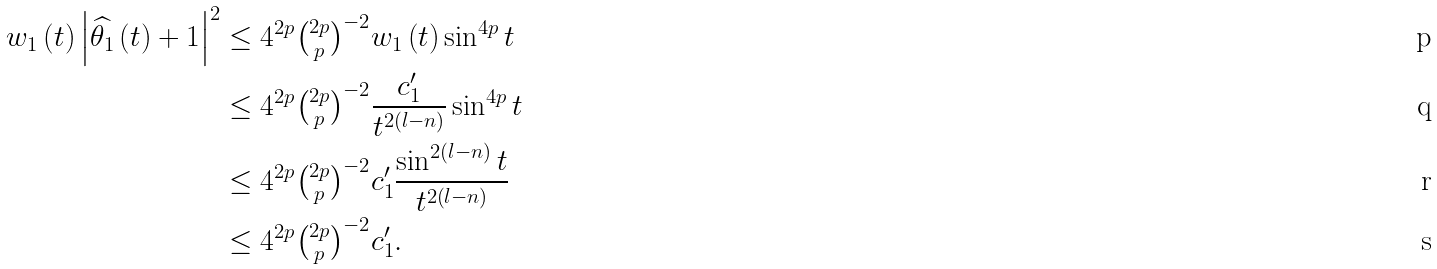<formula> <loc_0><loc_0><loc_500><loc_500>w _ { 1 } \left ( t \right ) \left | \widehat { \theta _ { 1 } } \left ( t \right ) + 1 \right | ^ { 2 } & \leq 4 ^ { 2 p } \tbinom { 2 p } { p } ^ { - 2 } w _ { 1 } \left ( t \right ) \sin ^ { 4 p } t \\ & \leq 4 ^ { 2 p } \tbinom { 2 p } { p } ^ { - 2 } \frac { c _ { 1 } ^ { \prime } } { t ^ { 2 \left ( l - n \right ) } } \sin ^ { 4 p } t \\ & \leq 4 ^ { 2 p } \tbinom { 2 p } { p } ^ { - 2 } c _ { 1 } ^ { \prime } \frac { \sin ^ { 2 \left ( l - n \right ) } t } { t ^ { 2 \left ( l - n \right ) } } \\ & \leq 4 ^ { 2 p } \tbinom { 2 p } { p } ^ { - 2 } c _ { 1 } ^ { \prime } .</formula> 